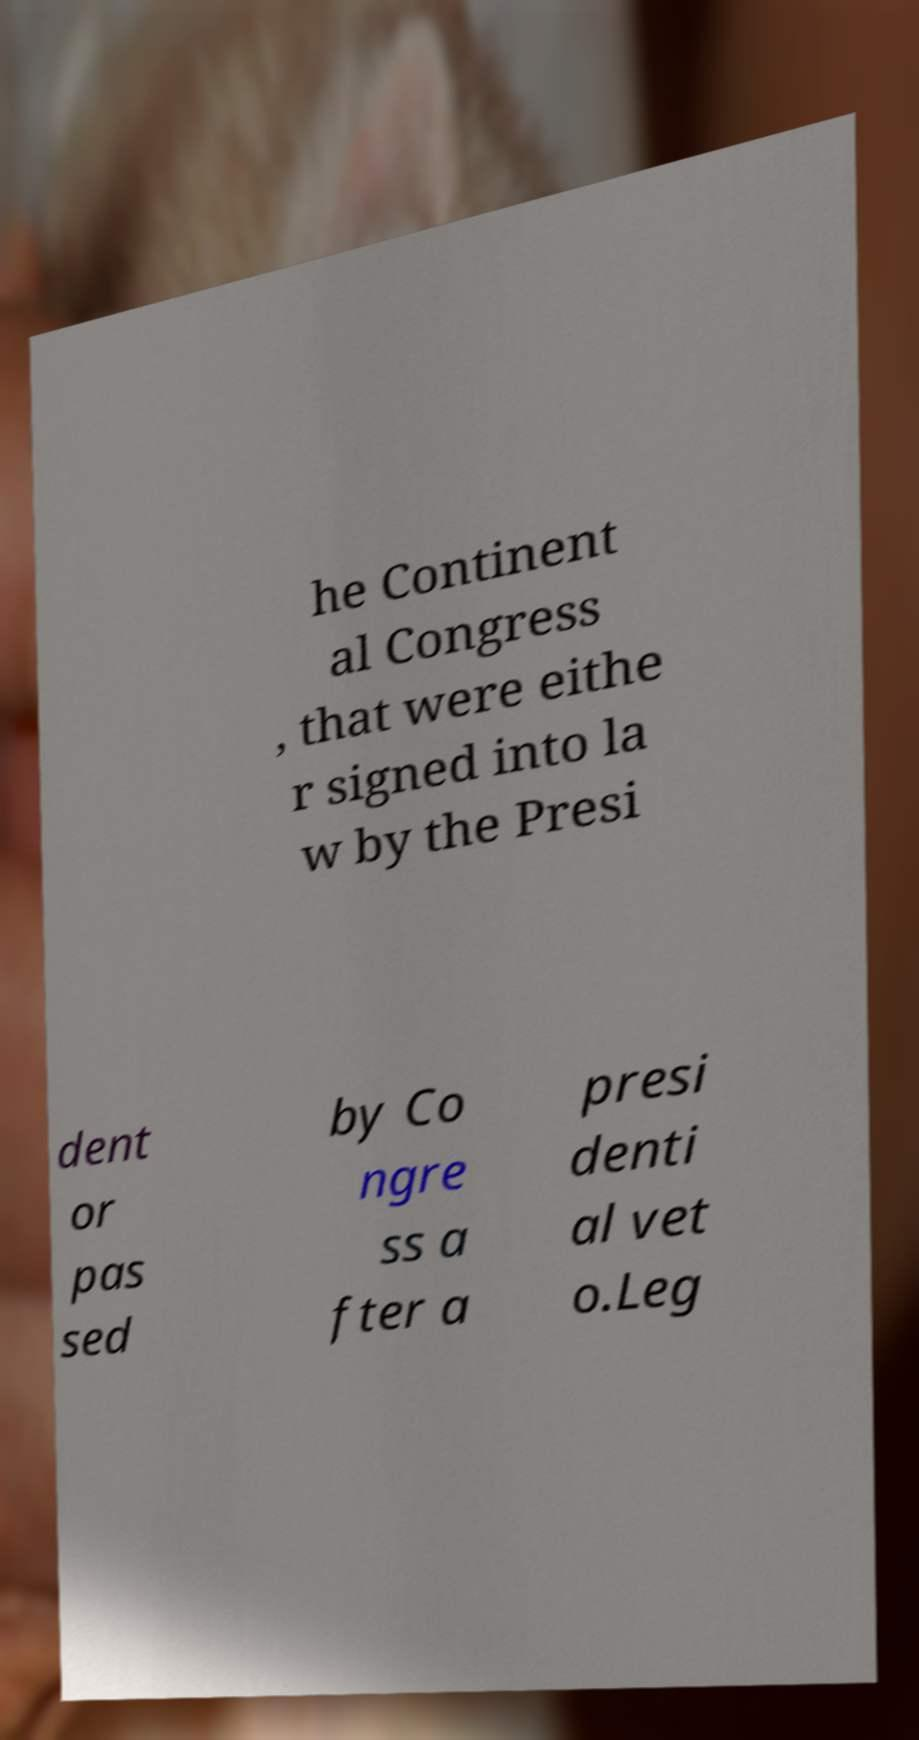Please read and relay the text visible in this image. What does it say? he Continent al Congress , that were eithe r signed into la w by the Presi dent or pas sed by Co ngre ss a fter a presi denti al vet o.Leg 